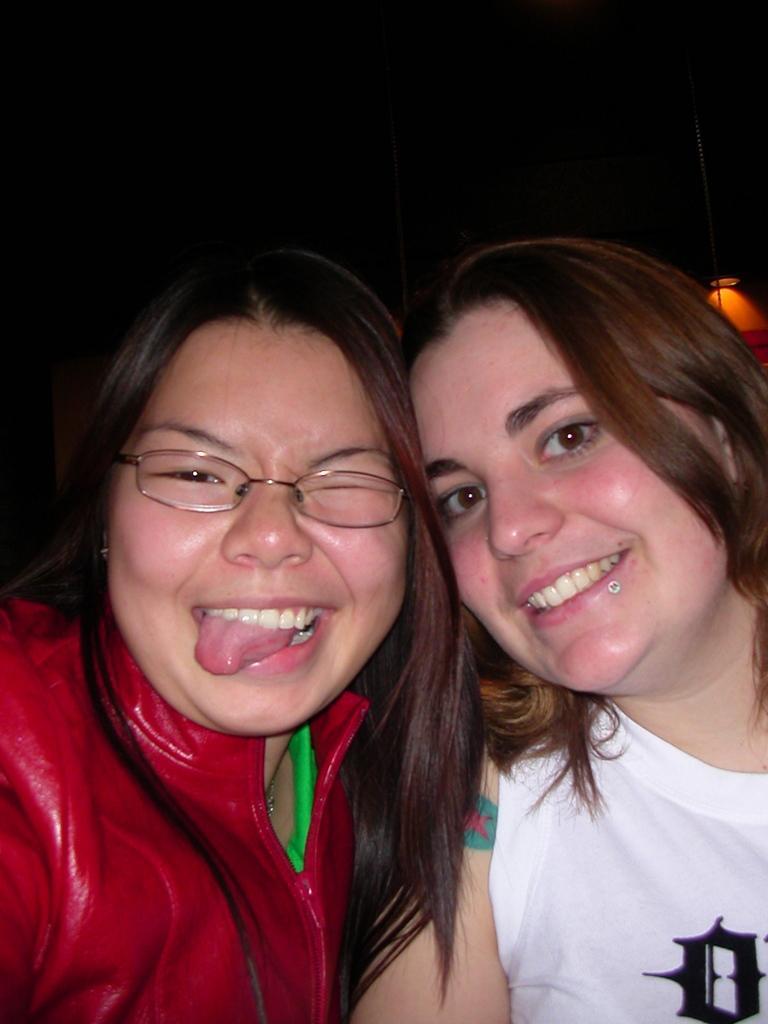How would you summarize this image in a sentence or two? In this picture I can see in the middle two women are there, they are smiling. 